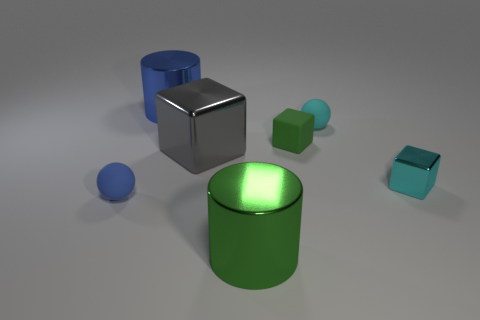There is a small cyan thing that is the same shape as the large gray thing; what material is it? The small cyan object appears to be made of plastic, characterized by its uniform color and matte finish, which is similar to the larger gray object that also exhibits properties indicative of plastic material. 